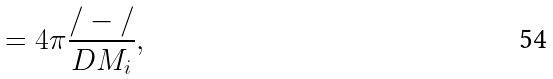<formula> <loc_0><loc_0><loc_500><loc_500>= 4 \pi \frac { / - / } { D M _ { i } } ,</formula> 